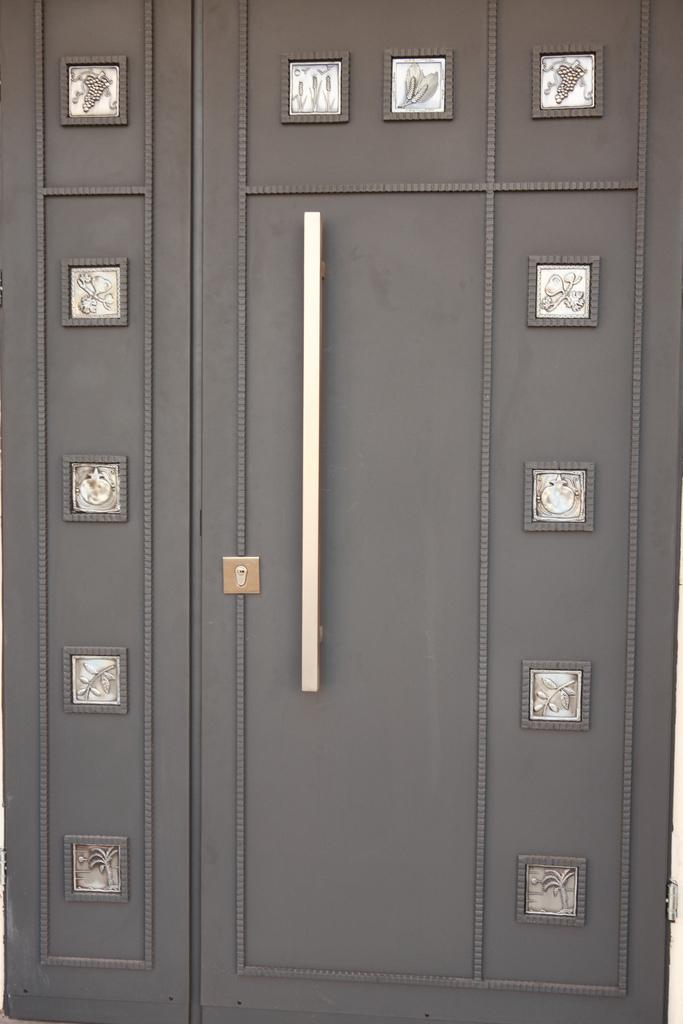What type of object is in the image? There is a locker in the image. What is the color of the locker? The locker is grey in color. What feature does the locker have for opening and closing? The locker has a handle. How is the locker secured? The locker has a lock. What can be seen on the surface of the locker? There are steel frames on the locker that resemble a pattern or design. Can you tell me the grade of the kitten playing in the basin in the image? There is no kitten or basin present in the image; it features a locker with a handle, lock, and steel frames. 